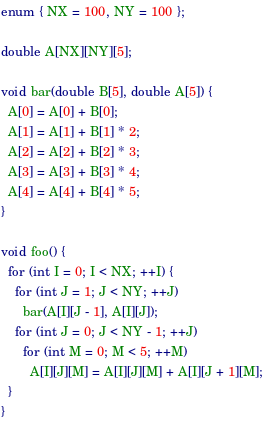Convert code to text. <code><loc_0><loc_0><loc_500><loc_500><_C_>enum { NX = 100, NY = 100 };

double A[NX][NY][5];

void bar(double B[5], double A[5]) {
  A[0] = A[0] + B[0];
  A[1] = A[1] + B[1] * 2;
  A[2] = A[2] + B[2] * 3;
  A[3] = A[3] + B[3] * 4;
  A[4] = A[4] + B[4] * 5;
}

void foo() {
  for (int I = 0; I < NX; ++I) {
    for (int J = 1; J < NY; ++J)
      bar(A[I][J - 1], A[I][J]);
    for (int J = 0; J < NY - 1; ++J)
      for (int M = 0; M < 5; ++M)
        A[I][J][M] = A[I][J][M] + A[I][J + 1][M];
  }
}
</code> 